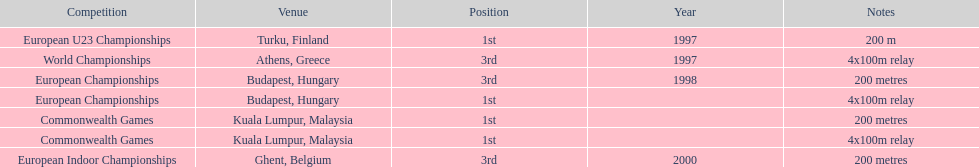How many total years did golding compete? 3. 